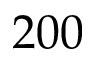<formula> <loc_0><loc_0><loc_500><loc_500>2 0 0</formula> 